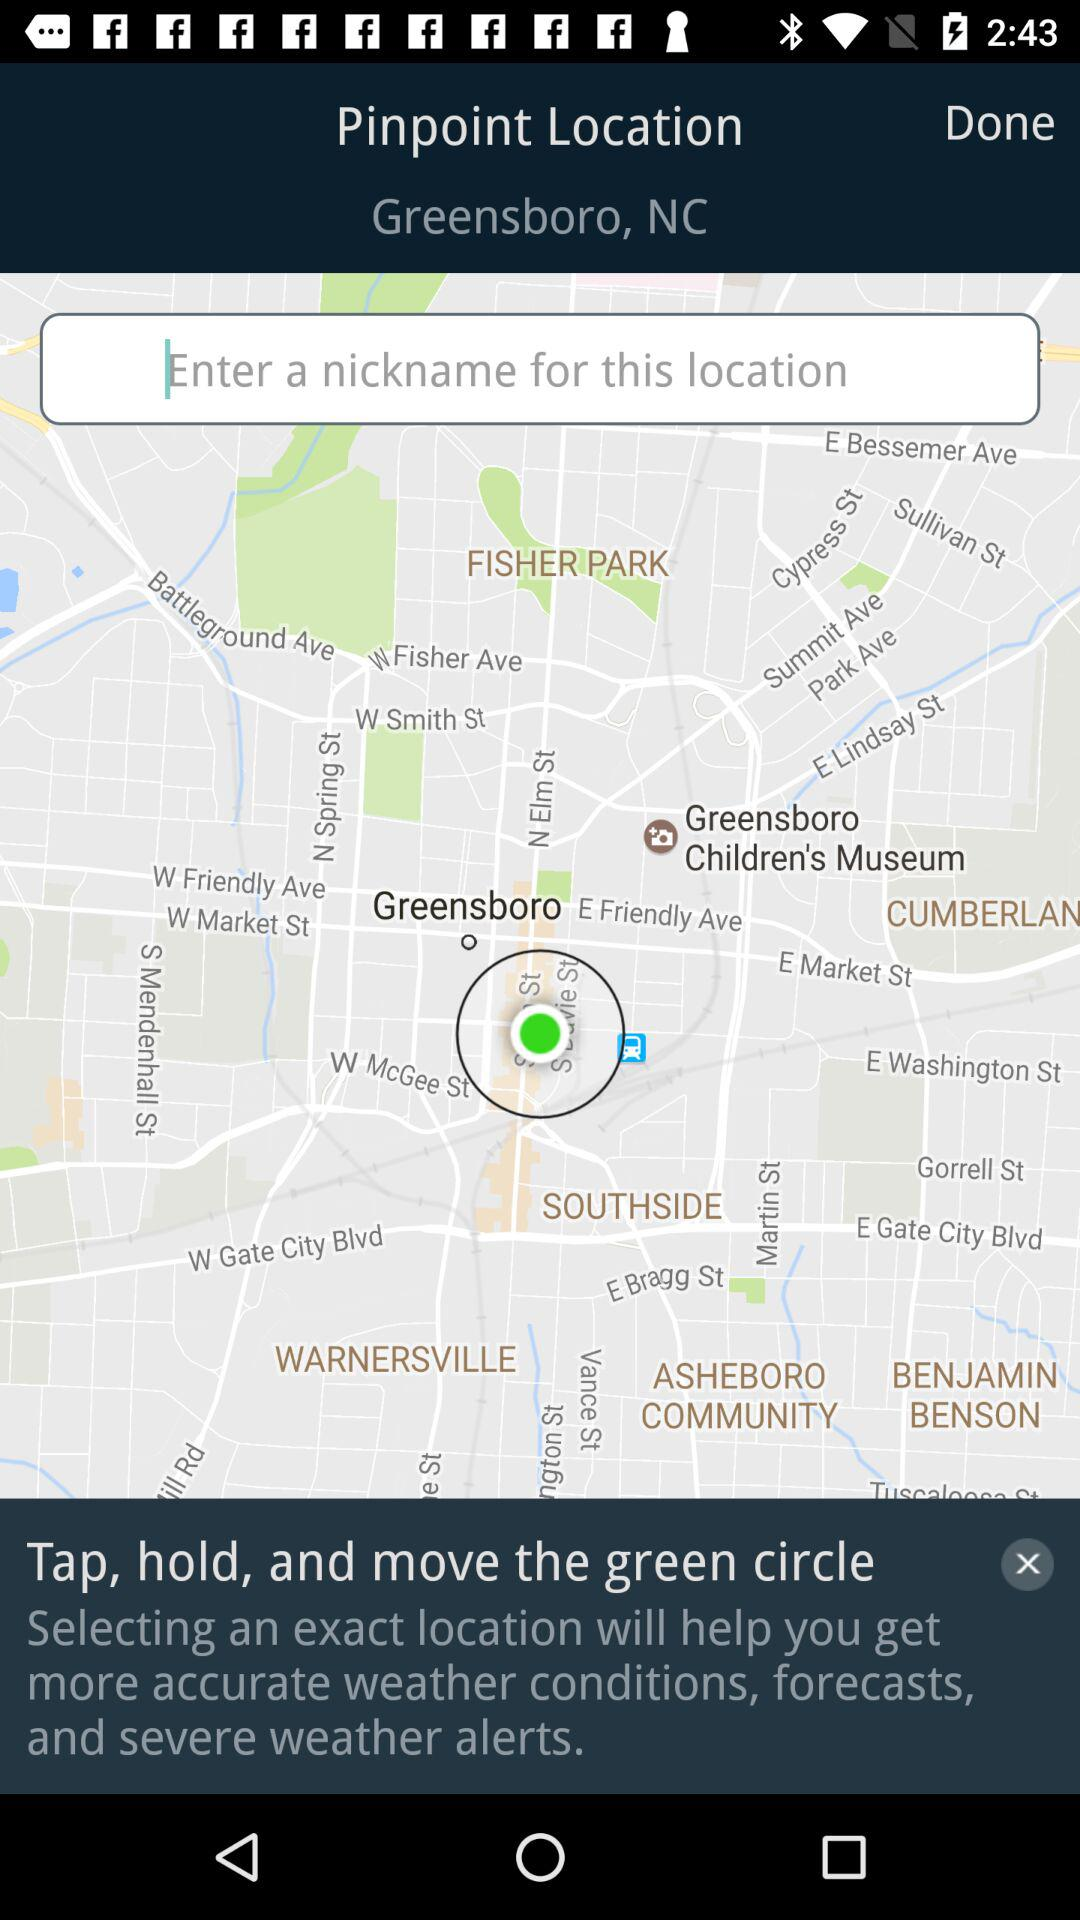How many text inputs are on the screen?
Answer the question using a single word or phrase. 1 